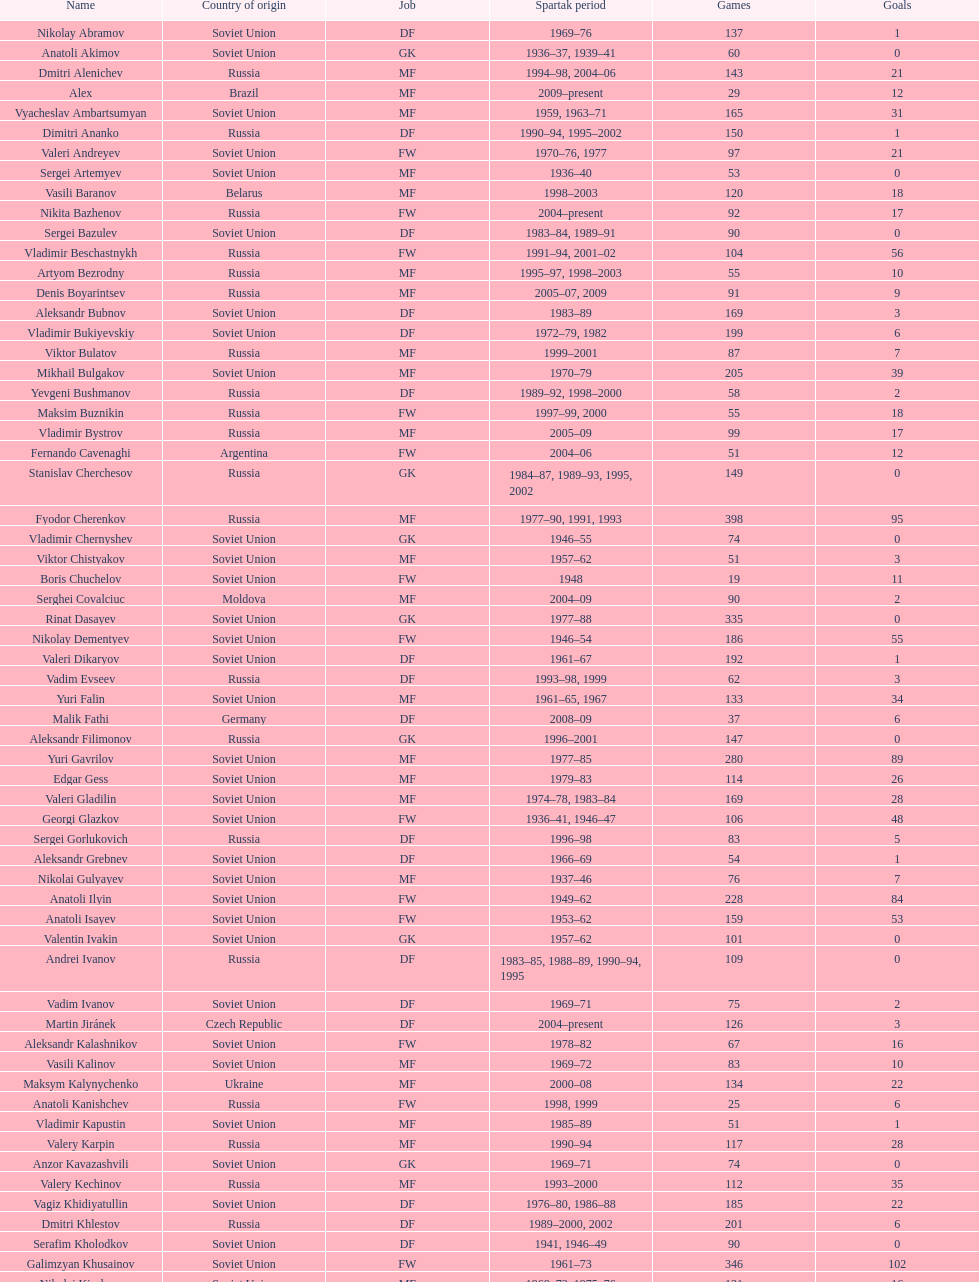Who had the highest number of appearances? Fyodor Cherenkov. 